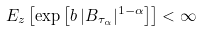<formula> <loc_0><loc_0><loc_500><loc_500>E _ { z } \left [ \exp \left [ { b \, | B _ { \tau _ { \alpha } } | ^ { 1 - \alpha } } \right ] \right ] < \infty</formula> 